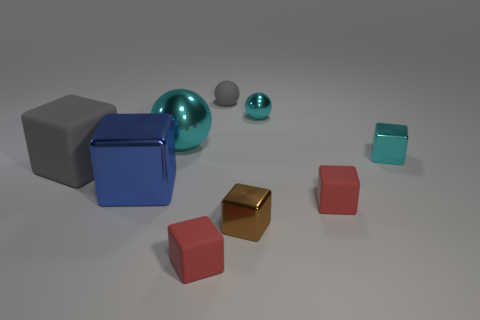There is a brown metallic object in front of the small red rubber thing that is behind the brown shiny cube; are there any gray cubes on the right side of it?
Provide a short and direct response. No. How many blocks are tiny cyan things or small things?
Your response must be concise. 4. What is the material of the gray object that is in front of the tiny cyan cube?
Keep it short and to the point. Rubber. What size is the block that is the same color as the rubber ball?
Your response must be concise. Large. Does the large metallic thing right of the large blue shiny object have the same color as the shiny cube behind the large gray thing?
Ensure brevity in your answer.  Yes. How many objects are either red matte cylinders or small rubber spheres?
Offer a very short reply. 1. How many other objects are there of the same shape as the big rubber object?
Provide a succinct answer. 5. Is the material of the cyan object that is left of the tiny gray rubber object the same as the gray thing behind the large gray matte cube?
Provide a succinct answer. No. The rubber thing that is on the left side of the tiny gray rubber object and right of the big cyan shiny object has what shape?
Your response must be concise. Cube. There is a block that is both on the left side of the tiny brown shiny block and behind the blue block; what is its material?
Offer a terse response. Rubber. 